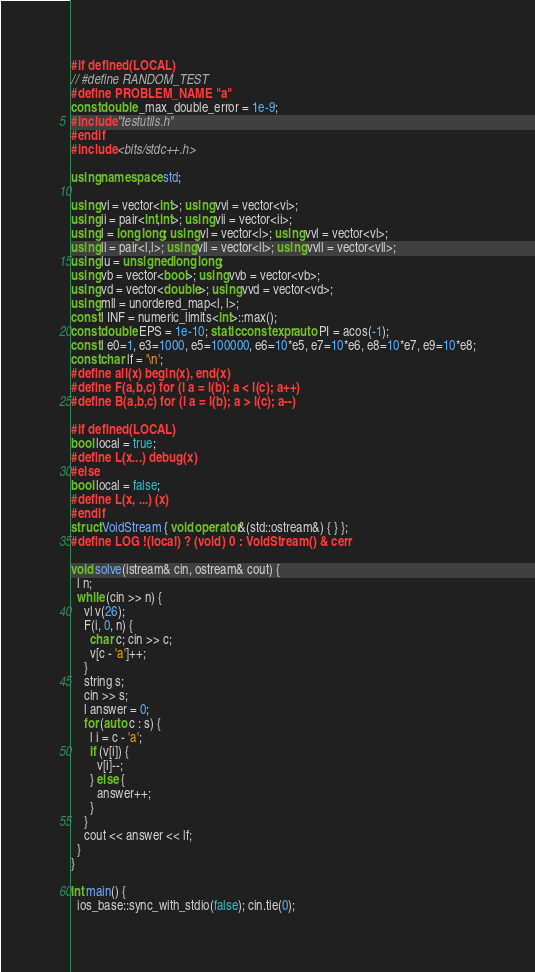Convert code to text. <code><loc_0><loc_0><loc_500><loc_500><_C++_>#if defined(LOCAL)
// #define RANDOM_TEST
#define PROBLEM_NAME "a"
const double _max_double_error = 1e-9;
#include "testutils.h"
#endif
#include <bits/stdc++.h>

using namespace std;

using vi = vector<int>; using vvi = vector<vi>;
using ii = pair<int,int>; using vii = vector<ii>;
using l = long long; using vl = vector<l>; using vvl = vector<vl>;
using ll = pair<l,l>; using vll = vector<ll>; using vvll = vector<vll>;
using lu = unsigned long long;
using vb = vector<bool>; using vvb = vector<vb>;
using vd = vector<double>; using vvd = vector<vd>;
using mll = unordered_map<l, l>;
const l INF = numeric_limits<int>::max();
const double EPS = 1e-10; static constexpr auto PI = acos(-1);
const l e0=1, e3=1000, e5=100000, e6=10*e5, e7=10*e6, e8=10*e7, e9=10*e8;
const char lf = '\n';
#define all(x) begin(x), end(x)
#define F(a,b,c) for (l a = l(b); a < l(c); a++)
#define B(a,b,c) for (l a = l(b); a > l(c); a--)

#if defined(LOCAL)
bool local = true;
#define L(x...) debug(x)
#else
bool local = false;
#define L(x, ...) (x)
#endif
struct VoidStream { void operator&(std::ostream&) { } };
#define LOG !(local) ? (void) 0 : VoidStream() & cerr

void solve(istream& cin, ostream& cout) {
  l n;
  while (cin >> n) {
    vl v(26);
    F(i, 0, n) {
      char c; cin >> c;
      v[c - 'a']++;
    }
    string s;
    cin >> s;
    l answer = 0;
    for (auto c : s) {
      l i = c - 'a';
      if (v[i]) {
        v[i]--;
      } else {
        answer++;
      }
    }
    cout << answer << lf;
  }
}

int main() {
  ios_base::sync_with_stdio(false); cin.tie(0);</code> 